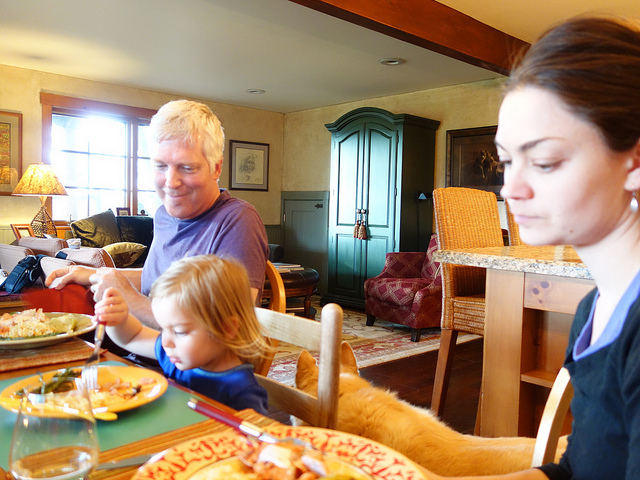How many chairs are in the picture? There are three chairs visible in the image, each with its unique placement and possibly being used by the family members gathered around the dining table for a meal. 